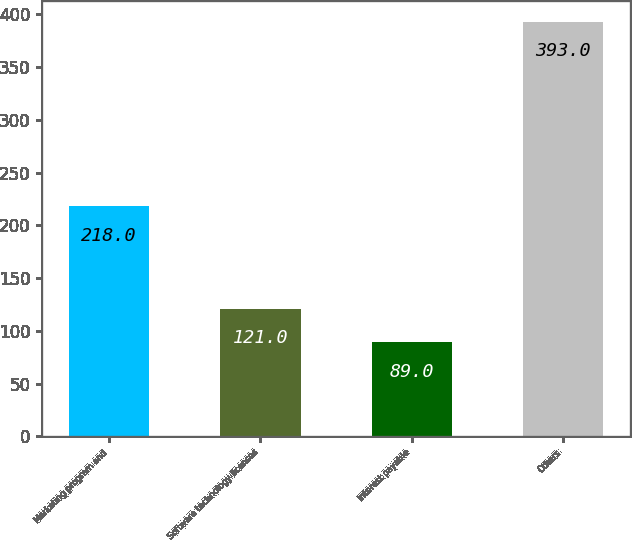Convert chart to OTSL. <chart><loc_0><loc_0><loc_500><loc_500><bar_chart><fcel>Marketing program and<fcel>Software technology licenses<fcel>Interest payable<fcel>Others<nl><fcel>218<fcel>121<fcel>89<fcel>393<nl></chart> 